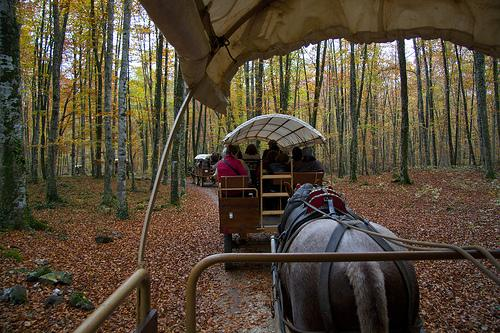What are the predominant colors in the image? The main colors in the image are brown, orange, and yellow due to the trees, leaves, and horses. Describe the scenery captured in the image. The image features a fall forest, filled with trees showcasing orange, brown, and red leaves. Identify the primary activity taking place in the image. People are riding in covered horse-drawn wagons through a forest during autumn. Mention the number of wagons and what covers them in the image. There are two horse-drawn wagons, each with a white tarp-covering its roof. Briefly describe the natural elements found in the image. The image showcases a fall forest, dead leaves on the ground, and moss growing on a tree trunk. State the type of transportation depicted in the image. The transportation in the image is a horse-drawn wagon with a covered roof. Comment on the state of the trees and the leaves on the ground. The trees in the image are in their fall colors, and there are orange, brown, and red leaves on the ground. Explain the state of the horse and the materials it is wearing. The horse is a dark brown color and is wearing a harness and straps to pull the wagon. What type of animal can be seen in the image and what is it doing? A brown horse is pulling a wagon with a white tarp-covered roof. Provide a detailed description of the primary attire worn in the image. A person wears a red shirt, girl with pink jacket and strap, and a lady with a yellow shirt. 